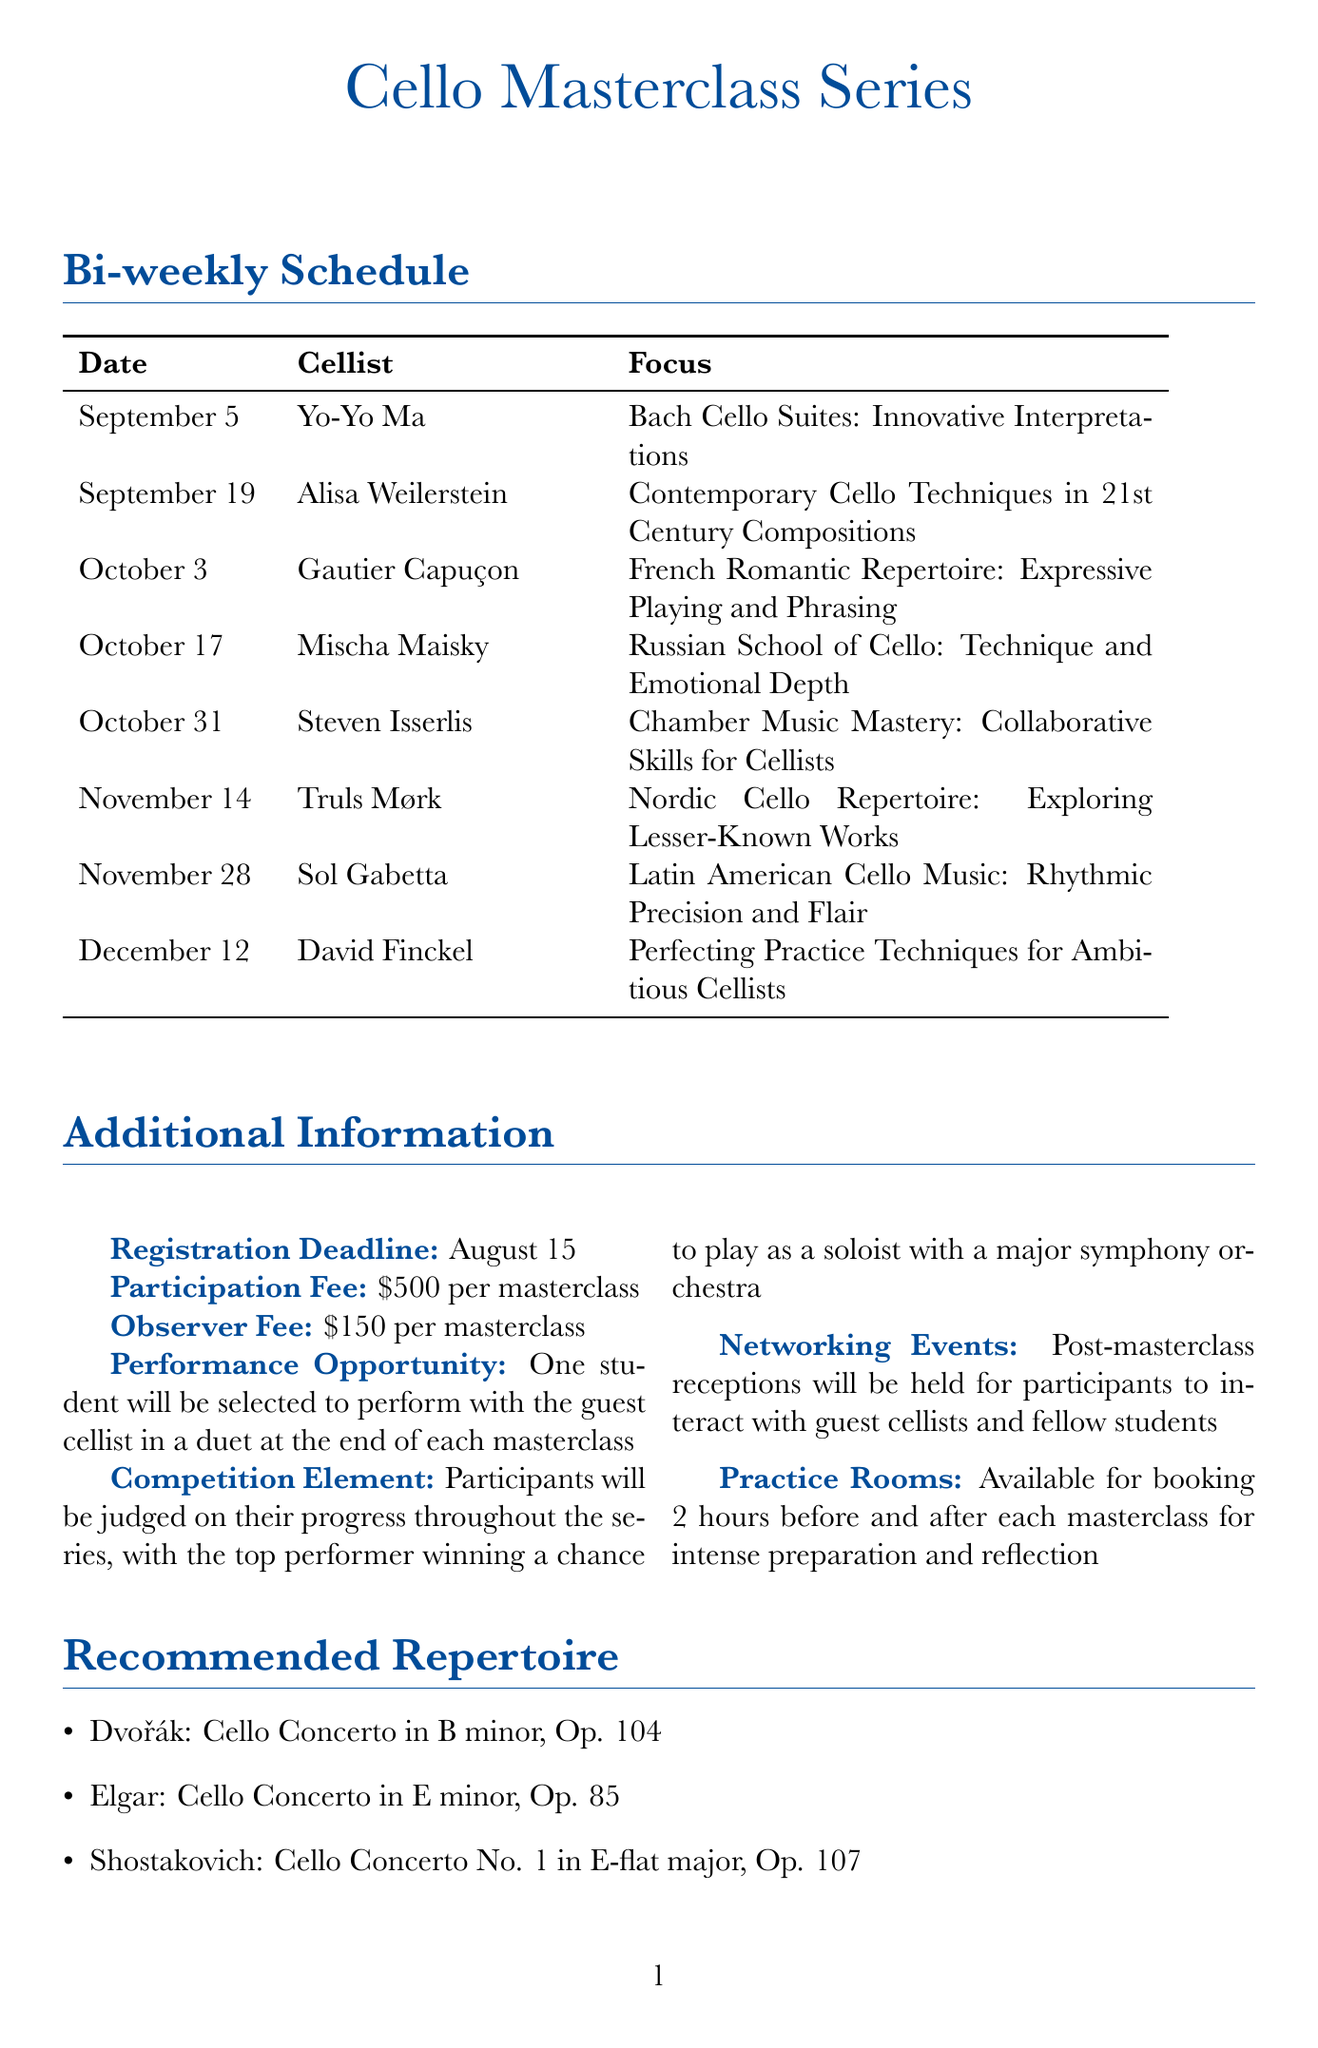What is the focus of Yo-Yo Ma's masterclass? The focus for Yo-Yo Ma's masterclass is described in the schedule under his name.
Answer: Bach Cello Suites: Innovative Interpretations Where is Alisa Weilerstein's masterclass held? The location of Alisa Weilerstein's masterclass is listed in the schedule.
Answer: Royal College of Music, London How long will the masterclass with Steven Isserlis last? The duration of Steven Isserlis's masterclass can be found in the schedule.
Answer: 3 hours What is the registration deadline for the masterclasses? The registration deadline is specified in the additional information section of the document.
Answer: August 15 What is the total fee for observers attending one masterclass? The observer fee is detailed in the additional information and gives a specific figure.
Answer: $150 Which cellist focuses on Nordic Cello Repertoire? The name of the cellist focusing on Nordic Cello Repertoire is stated in the document.
Answer: Truls Mørk How many hours are practice rooms available for booking before each masterclass? This information is mentioned in the additional information section regarding practice rooms.
Answer: 2 hours What is the focus of the masterclass held on October 3? The specific focus of the masterclass on October 3 is listed in the schedule.
Answer: French Romantic Repertoire: Expressive Playing and Phrasing 